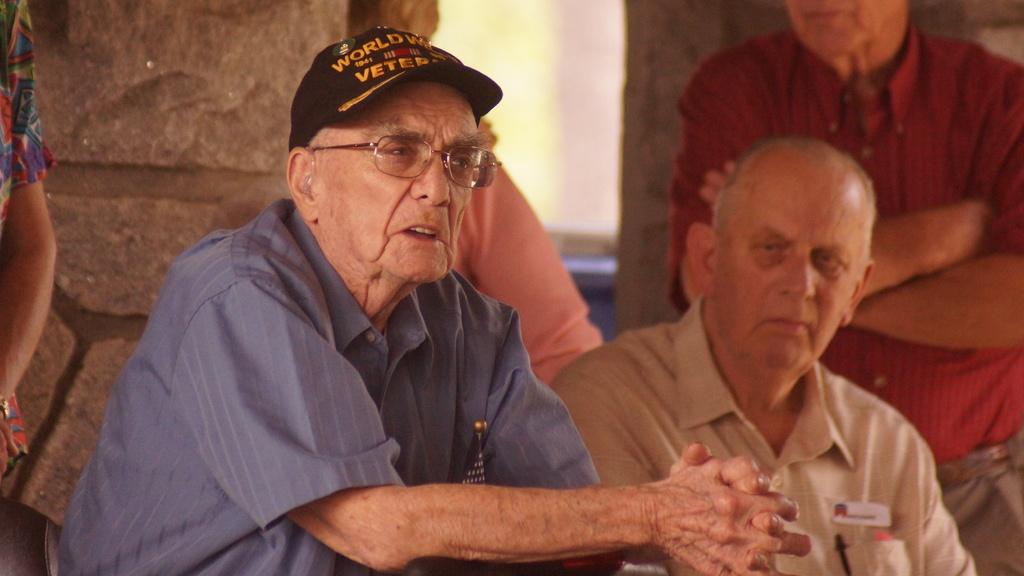Describe this image in one or two sentences. There is a person in gray color shirt standing, keeping both hands on a stand and speaking near a person who is sitting on a chair. In the background, there are other persons standing and there is a pillar. 